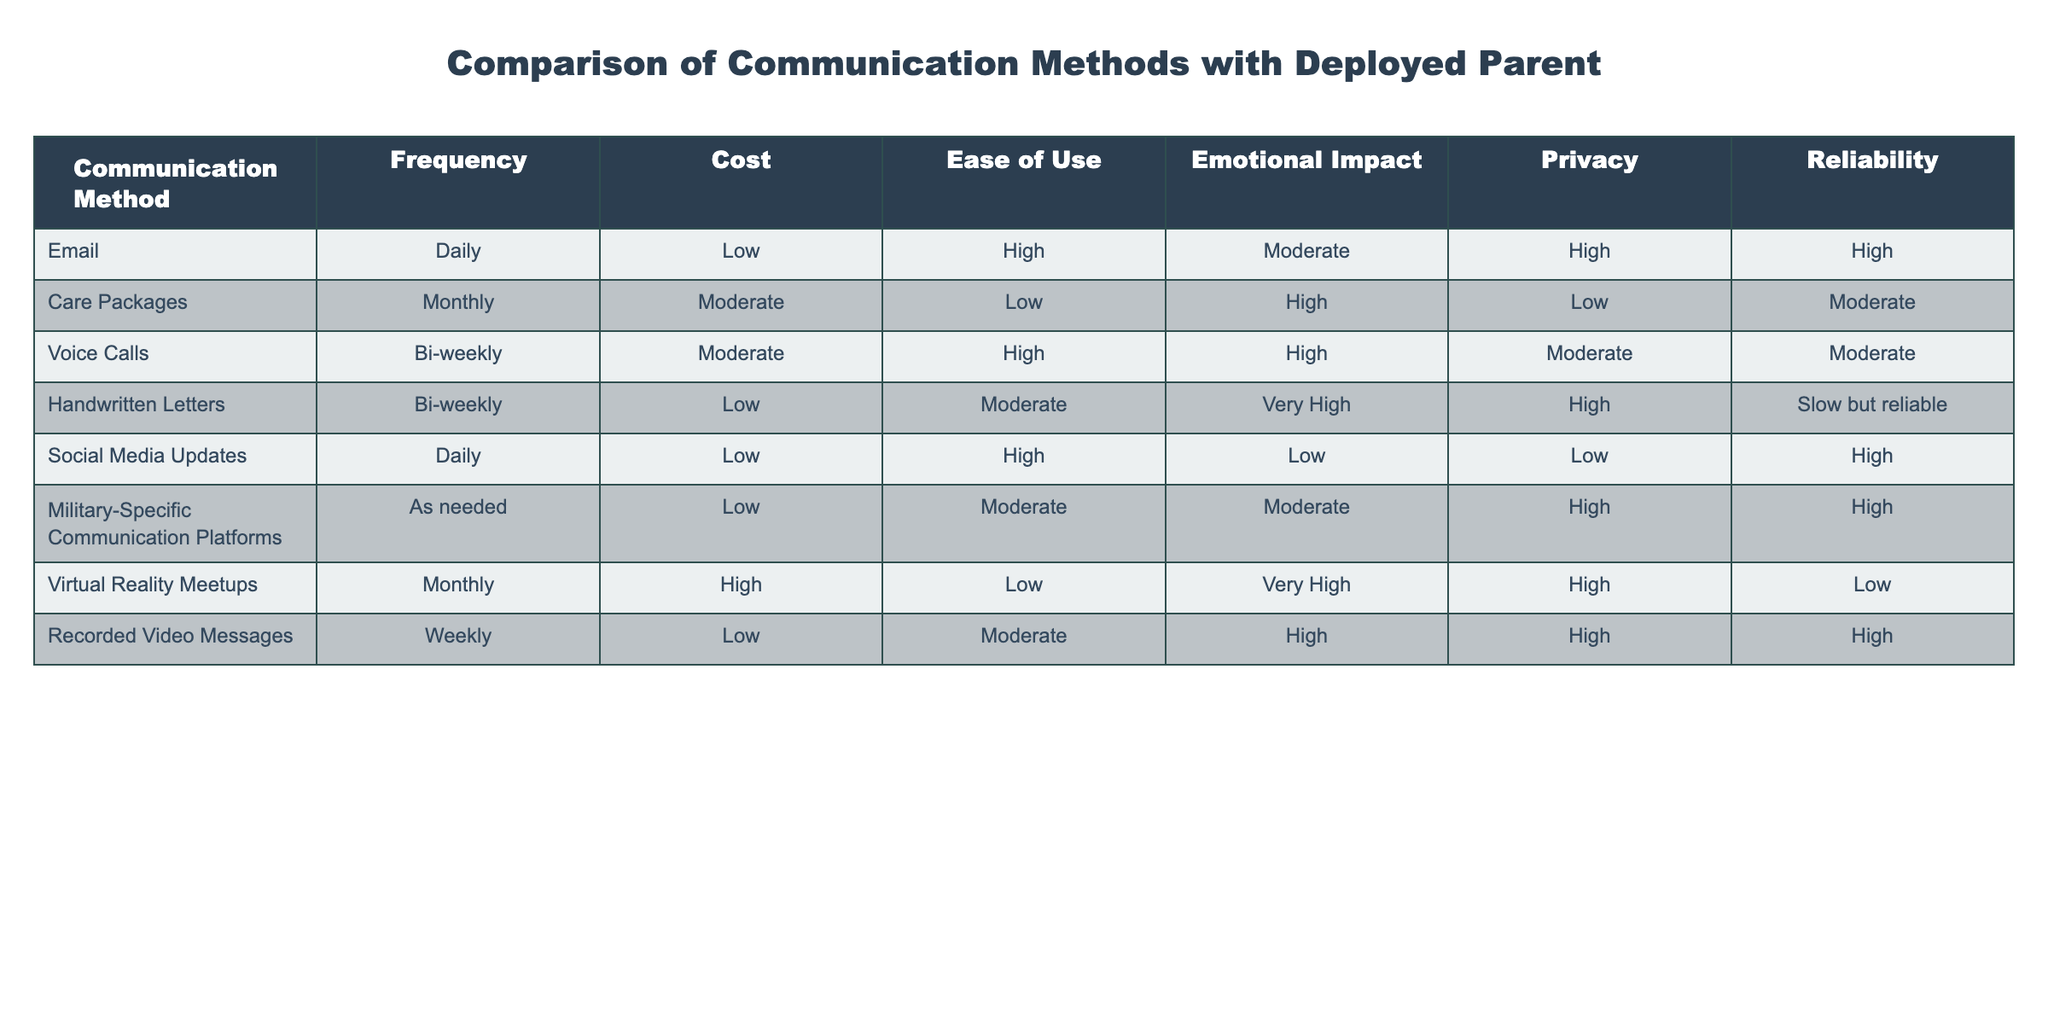What is the emotional impact of handwritten letters? According to the table, handwritten letters have an emotional impact rating of "Very High."
Answer: Very High How often are care packages sent? The table states that care packages are sent on a monthly basis.
Answer: Monthly Which communication method has the highest ease of use? Email and social media updates both have a high ease of use rating according to the table.
Answer: Email and Social Media Updates What is the cost of voice calls? The table indicates that the cost of voice calls is moderate.
Answer: Moderate Is the reliability of virtual reality meetups low? The table shows that virtual reality meetups have a reliability rating of low, confirming the statement is true.
Answer: Yes Which method is used most frequently, and what is its emotional impact? The most frequently used method is email, which has a moderate emotional impact rating. This is determined by looking at the frequency column where email is noted as daily while emotional impact is "Moderate."
Answer: Email, Moderate Emotional Impact How does the privacy level of recorded video messages compare to email? Recorded video messages have a high privacy level, which is the same as email. By comparing the privacy ratings in the table, both methods are rated high, indicating no difference in privacy.
Answer: Same (High) What is the sum of the cost ratings for all methods? The cost ratings are categorized as Low, Moderate, and High. Assigning numbers, Low = 1, Moderate = 2, High = 3: Email (1) + Care Packages (2) + Voice Calls (2) + Handwritten Letters (1) + Social Media Updates (1) + Military Platforms (1) + Virtual Reality (3) + Recorded Video Messages (1) = 12.
Answer: 12 Which method has the highest emotional impact and how often is it used? Handwritten letters have the highest emotional impact at "Very High" which is used bi-weekly. By checking the emotional impact column, this can be confirmed.
Answer: Handwritten Letters, Bi-weekly 